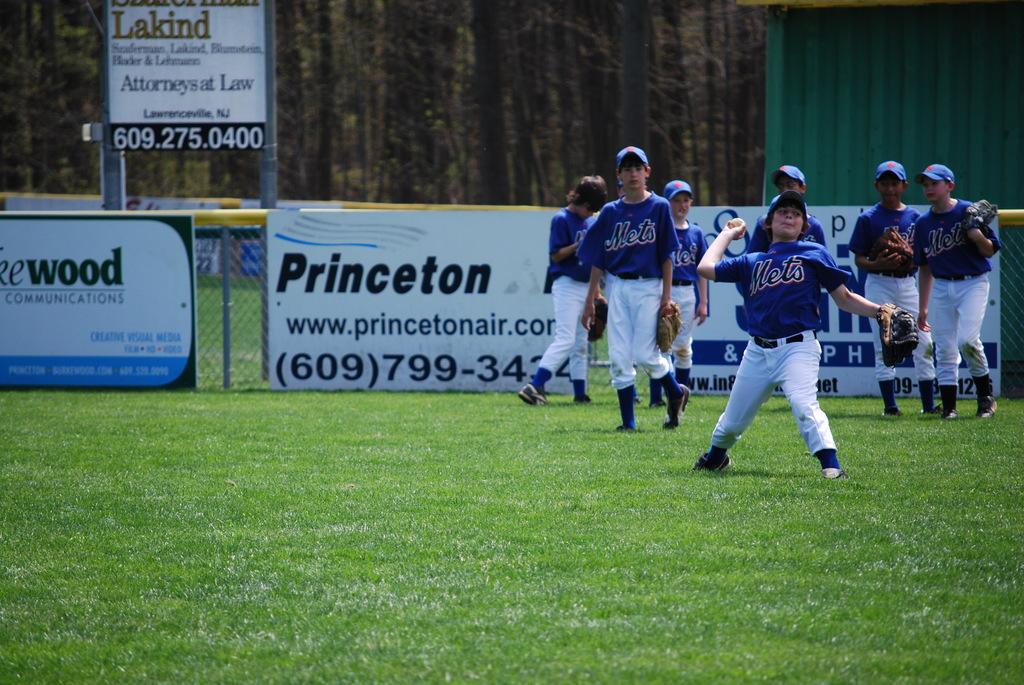Who is a sponsor?
Ensure brevity in your answer.  Princeton. 